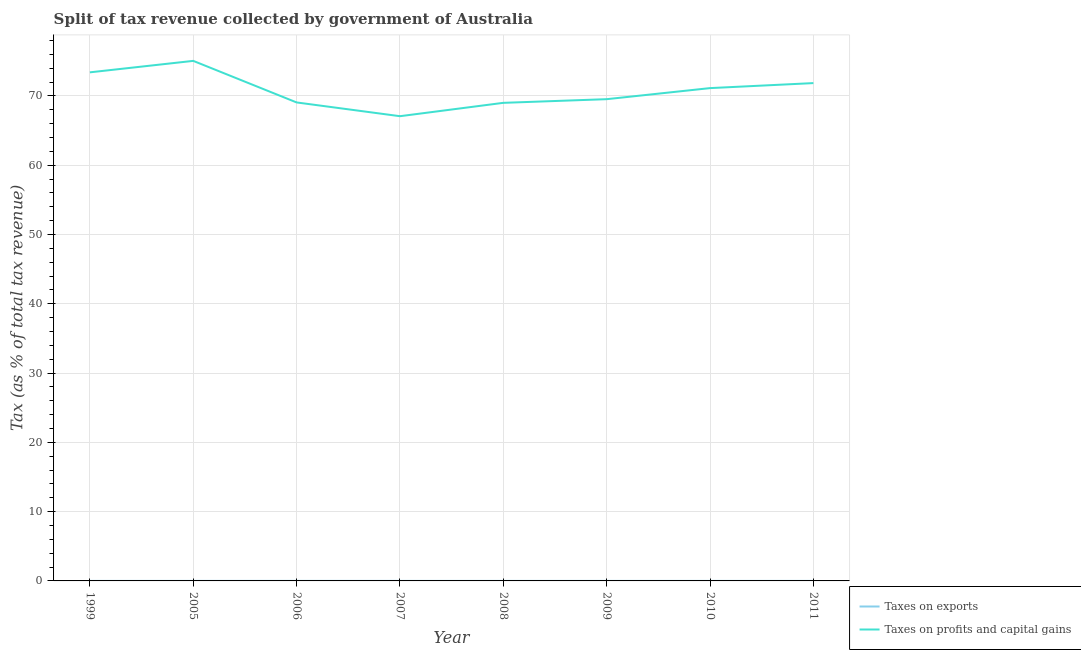Is the number of lines equal to the number of legend labels?
Make the answer very short. Yes. What is the percentage of revenue obtained from taxes on exports in 2006?
Provide a succinct answer. 0.01. Across all years, what is the maximum percentage of revenue obtained from taxes on exports?
Make the answer very short. 0.01. Across all years, what is the minimum percentage of revenue obtained from taxes on profits and capital gains?
Offer a terse response. 67.07. What is the total percentage of revenue obtained from taxes on profits and capital gains in the graph?
Offer a terse response. 566.1. What is the difference between the percentage of revenue obtained from taxes on profits and capital gains in 2009 and that in 2010?
Your answer should be very brief. -1.6. What is the difference between the percentage of revenue obtained from taxes on exports in 2007 and the percentage of revenue obtained from taxes on profits and capital gains in 2010?
Keep it short and to the point. -71.12. What is the average percentage of revenue obtained from taxes on profits and capital gains per year?
Offer a very short reply. 70.76. In the year 2007, what is the difference between the percentage of revenue obtained from taxes on profits and capital gains and percentage of revenue obtained from taxes on exports?
Keep it short and to the point. 67.07. What is the ratio of the percentage of revenue obtained from taxes on exports in 2008 to that in 2010?
Make the answer very short. 0.67. Is the percentage of revenue obtained from taxes on exports in 2005 less than that in 2006?
Keep it short and to the point. Yes. What is the difference between the highest and the second highest percentage of revenue obtained from taxes on profits and capital gains?
Your response must be concise. 1.65. What is the difference between the highest and the lowest percentage of revenue obtained from taxes on profits and capital gains?
Your answer should be very brief. 7.98. In how many years, is the percentage of revenue obtained from taxes on profits and capital gains greater than the average percentage of revenue obtained from taxes on profits and capital gains taken over all years?
Keep it short and to the point. 4. Is the percentage of revenue obtained from taxes on profits and capital gains strictly less than the percentage of revenue obtained from taxes on exports over the years?
Offer a terse response. No. How many lines are there?
Keep it short and to the point. 2. Are the values on the major ticks of Y-axis written in scientific E-notation?
Make the answer very short. No. Does the graph contain any zero values?
Keep it short and to the point. No. Does the graph contain grids?
Offer a very short reply. Yes. Where does the legend appear in the graph?
Keep it short and to the point. Bottom right. How many legend labels are there?
Your answer should be very brief. 2. How are the legend labels stacked?
Your response must be concise. Vertical. What is the title of the graph?
Your response must be concise. Split of tax revenue collected by government of Australia. Does "Mineral" appear as one of the legend labels in the graph?
Your answer should be compact. No. What is the label or title of the Y-axis?
Provide a succinct answer. Tax (as % of total tax revenue). What is the Tax (as % of total tax revenue) in Taxes on exports in 1999?
Your answer should be very brief. 0. What is the Tax (as % of total tax revenue) of Taxes on profits and capital gains in 1999?
Your answer should be compact. 73.4. What is the Tax (as % of total tax revenue) of Taxes on exports in 2005?
Offer a very short reply. 0.01. What is the Tax (as % of total tax revenue) of Taxes on profits and capital gains in 2005?
Give a very brief answer. 75.06. What is the Tax (as % of total tax revenue) of Taxes on exports in 2006?
Provide a succinct answer. 0.01. What is the Tax (as % of total tax revenue) in Taxes on profits and capital gains in 2006?
Make the answer very short. 69.06. What is the Tax (as % of total tax revenue) in Taxes on exports in 2007?
Give a very brief answer. 0.01. What is the Tax (as % of total tax revenue) of Taxes on profits and capital gains in 2007?
Your response must be concise. 67.07. What is the Tax (as % of total tax revenue) in Taxes on exports in 2008?
Provide a succinct answer. 0. What is the Tax (as % of total tax revenue) of Taxes on profits and capital gains in 2008?
Ensure brevity in your answer.  69. What is the Tax (as % of total tax revenue) in Taxes on exports in 2009?
Keep it short and to the point. 0. What is the Tax (as % of total tax revenue) of Taxes on profits and capital gains in 2009?
Ensure brevity in your answer.  69.53. What is the Tax (as % of total tax revenue) in Taxes on exports in 2010?
Ensure brevity in your answer.  0.01. What is the Tax (as % of total tax revenue) in Taxes on profits and capital gains in 2010?
Your response must be concise. 71.13. What is the Tax (as % of total tax revenue) in Taxes on exports in 2011?
Provide a succinct answer. 0. What is the Tax (as % of total tax revenue) of Taxes on profits and capital gains in 2011?
Your answer should be compact. 71.85. Across all years, what is the maximum Tax (as % of total tax revenue) in Taxes on exports?
Keep it short and to the point. 0.01. Across all years, what is the maximum Tax (as % of total tax revenue) in Taxes on profits and capital gains?
Your response must be concise. 75.06. Across all years, what is the minimum Tax (as % of total tax revenue) in Taxes on exports?
Provide a short and direct response. 0. Across all years, what is the minimum Tax (as % of total tax revenue) in Taxes on profits and capital gains?
Give a very brief answer. 67.07. What is the total Tax (as % of total tax revenue) of Taxes on exports in the graph?
Give a very brief answer. 0.04. What is the total Tax (as % of total tax revenue) of Taxes on profits and capital gains in the graph?
Ensure brevity in your answer.  566.1. What is the difference between the Tax (as % of total tax revenue) of Taxes on exports in 1999 and that in 2005?
Give a very brief answer. -0. What is the difference between the Tax (as % of total tax revenue) in Taxes on profits and capital gains in 1999 and that in 2005?
Make the answer very short. -1.65. What is the difference between the Tax (as % of total tax revenue) of Taxes on exports in 1999 and that in 2006?
Give a very brief answer. -0. What is the difference between the Tax (as % of total tax revenue) of Taxes on profits and capital gains in 1999 and that in 2006?
Offer a terse response. 4.34. What is the difference between the Tax (as % of total tax revenue) in Taxes on exports in 1999 and that in 2007?
Offer a terse response. -0. What is the difference between the Tax (as % of total tax revenue) in Taxes on profits and capital gains in 1999 and that in 2007?
Provide a short and direct response. 6.33. What is the difference between the Tax (as % of total tax revenue) in Taxes on exports in 1999 and that in 2008?
Your answer should be compact. -0. What is the difference between the Tax (as % of total tax revenue) of Taxes on profits and capital gains in 1999 and that in 2008?
Your response must be concise. 4.4. What is the difference between the Tax (as % of total tax revenue) of Taxes on exports in 1999 and that in 2009?
Provide a short and direct response. -0. What is the difference between the Tax (as % of total tax revenue) of Taxes on profits and capital gains in 1999 and that in 2009?
Provide a succinct answer. 3.87. What is the difference between the Tax (as % of total tax revenue) of Taxes on exports in 1999 and that in 2010?
Your response must be concise. -0. What is the difference between the Tax (as % of total tax revenue) of Taxes on profits and capital gains in 1999 and that in 2010?
Give a very brief answer. 2.28. What is the difference between the Tax (as % of total tax revenue) of Taxes on exports in 1999 and that in 2011?
Make the answer very short. -0. What is the difference between the Tax (as % of total tax revenue) in Taxes on profits and capital gains in 1999 and that in 2011?
Provide a succinct answer. 1.55. What is the difference between the Tax (as % of total tax revenue) in Taxes on exports in 2005 and that in 2006?
Give a very brief answer. -0. What is the difference between the Tax (as % of total tax revenue) of Taxes on profits and capital gains in 2005 and that in 2006?
Give a very brief answer. 6. What is the difference between the Tax (as % of total tax revenue) in Taxes on exports in 2005 and that in 2007?
Your answer should be compact. -0. What is the difference between the Tax (as % of total tax revenue) in Taxes on profits and capital gains in 2005 and that in 2007?
Offer a terse response. 7.98. What is the difference between the Tax (as % of total tax revenue) of Taxes on exports in 2005 and that in 2008?
Give a very brief answer. 0. What is the difference between the Tax (as % of total tax revenue) in Taxes on profits and capital gains in 2005 and that in 2008?
Your response must be concise. 6.06. What is the difference between the Tax (as % of total tax revenue) in Taxes on exports in 2005 and that in 2009?
Make the answer very short. 0. What is the difference between the Tax (as % of total tax revenue) of Taxes on profits and capital gains in 2005 and that in 2009?
Provide a short and direct response. 5.53. What is the difference between the Tax (as % of total tax revenue) in Taxes on profits and capital gains in 2005 and that in 2010?
Give a very brief answer. 3.93. What is the difference between the Tax (as % of total tax revenue) in Taxes on exports in 2005 and that in 2011?
Provide a short and direct response. 0. What is the difference between the Tax (as % of total tax revenue) of Taxes on profits and capital gains in 2005 and that in 2011?
Offer a terse response. 3.21. What is the difference between the Tax (as % of total tax revenue) of Taxes on exports in 2006 and that in 2007?
Make the answer very short. 0. What is the difference between the Tax (as % of total tax revenue) of Taxes on profits and capital gains in 2006 and that in 2007?
Give a very brief answer. 1.98. What is the difference between the Tax (as % of total tax revenue) in Taxes on exports in 2006 and that in 2008?
Give a very brief answer. 0. What is the difference between the Tax (as % of total tax revenue) of Taxes on profits and capital gains in 2006 and that in 2008?
Ensure brevity in your answer.  0.06. What is the difference between the Tax (as % of total tax revenue) of Taxes on exports in 2006 and that in 2009?
Give a very brief answer. 0. What is the difference between the Tax (as % of total tax revenue) of Taxes on profits and capital gains in 2006 and that in 2009?
Your answer should be very brief. -0.47. What is the difference between the Tax (as % of total tax revenue) of Taxes on profits and capital gains in 2006 and that in 2010?
Offer a terse response. -2.07. What is the difference between the Tax (as % of total tax revenue) of Taxes on exports in 2006 and that in 2011?
Make the answer very short. 0. What is the difference between the Tax (as % of total tax revenue) of Taxes on profits and capital gains in 2006 and that in 2011?
Offer a terse response. -2.79. What is the difference between the Tax (as % of total tax revenue) of Taxes on exports in 2007 and that in 2008?
Provide a succinct answer. 0. What is the difference between the Tax (as % of total tax revenue) of Taxes on profits and capital gains in 2007 and that in 2008?
Ensure brevity in your answer.  -1.93. What is the difference between the Tax (as % of total tax revenue) of Taxes on exports in 2007 and that in 2009?
Your response must be concise. 0. What is the difference between the Tax (as % of total tax revenue) of Taxes on profits and capital gains in 2007 and that in 2009?
Your answer should be compact. -2.46. What is the difference between the Tax (as % of total tax revenue) in Taxes on exports in 2007 and that in 2010?
Give a very brief answer. 0. What is the difference between the Tax (as % of total tax revenue) in Taxes on profits and capital gains in 2007 and that in 2010?
Give a very brief answer. -4.05. What is the difference between the Tax (as % of total tax revenue) of Taxes on exports in 2007 and that in 2011?
Give a very brief answer. 0. What is the difference between the Tax (as % of total tax revenue) in Taxes on profits and capital gains in 2007 and that in 2011?
Your response must be concise. -4.78. What is the difference between the Tax (as % of total tax revenue) of Taxes on exports in 2008 and that in 2009?
Give a very brief answer. -0. What is the difference between the Tax (as % of total tax revenue) in Taxes on profits and capital gains in 2008 and that in 2009?
Your answer should be compact. -0.53. What is the difference between the Tax (as % of total tax revenue) of Taxes on exports in 2008 and that in 2010?
Provide a succinct answer. -0. What is the difference between the Tax (as % of total tax revenue) in Taxes on profits and capital gains in 2008 and that in 2010?
Your answer should be very brief. -2.13. What is the difference between the Tax (as % of total tax revenue) in Taxes on exports in 2008 and that in 2011?
Your response must be concise. -0. What is the difference between the Tax (as % of total tax revenue) of Taxes on profits and capital gains in 2008 and that in 2011?
Your answer should be compact. -2.85. What is the difference between the Tax (as % of total tax revenue) of Taxes on exports in 2009 and that in 2010?
Your answer should be very brief. -0. What is the difference between the Tax (as % of total tax revenue) of Taxes on profits and capital gains in 2009 and that in 2010?
Keep it short and to the point. -1.6. What is the difference between the Tax (as % of total tax revenue) of Taxes on exports in 2009 and that in 2011?
Provide a short and direct response. 0. What is the difference between the Tax (as % of total tax revenue) of Taxes on profits and capital gains in 2009 and that in 2011?
Your answer should be compact. -2.32. What is the difference between the Tax (as % of total tax revenue) of Taxes on exports in 2010 and that in 2011?
Keep it short and to the point. 0. What is the difference between the Tax (as % of total tax revenue) of Taxes on profits and capital gains in 2010 and that in 2011?
Offer a very short reply. -0.72. What is the difference between the Tax (as % of total tax revenue) of Taxes on exports in 1999 and the Tax (as % of total tax revenue) of Taxes on profits and capital gains in 2005?
Your answer should be very brief. -75.05. What is the difference between the Tax (as % of total tax revenue) of Taxes on exports in 1999 and the Tax (as % of total tax revenue) of Taxes on profits and capital gains in 2006?
Your answer should be compact. -69.06. What is the difference between the Tax (as % of total tax revenue) in Taxes on exports in 1999 and the Tax (as % of total tax revenue) in Taxes on profits and capital gains in 2007?
Offer a terse response. -67.07. What is the difference between the Tax (as % of total tax revenue) in Taxes on exports in 1999 and the Tax (as % of total tax revenue) in Taxes on profits and capital gains in 2008?
Your answer should be very brief. -69. What is the difference between the Tax (as % of total tax revenue) in Taxes on exports in 1999 and the Tax (as % of total tax revenue) in Taxes on profits and capital gains in 2009?
Offer a very short reply. -69.53. What is the difference between the Tax (as % of total tax revenue) of Taxes on exports in 1999 and the Tax (as % of total tax revenue) of Taxes on profits and capital gains in 2010?
Your answer should be compact. -71.12. What is the difference between the Tax (as % of total tax revenue) of Taxes on exports in 1999 and the Tax (as % of total tax revenue) of Taxes on profits and capital gains in 2011?
Offer a terse response. -71.85. What is the difference between the Tax (as % of total tax revenue) in Taxes on exports in 2005 and the Tax (as % of total tax revenue) in Taxes on profits and capital gains in 2006?
Offer a very short reply. -69.05. What is the difference between the Tax (as % of total tax revenue) of Taxes on exports in 2005 and the Tax (as % of total tax revenue) of Taxes on profits and capital gains in 2007?
Offer a very short reply. -67.07. What is the difference between the Tax (as % of total tax revenue) of Taxes on exports in 2005 and the Tax (as % of total tax revenue) of Taxes on profits and capital gains in 2008?
Give a very brief answer. -69. What is the difference between the Tax (as % of total tax revenue) of Taxes on exports in 2005 and the Tax (as % of total tax revenue) of Taxes on profits and capital gains in 2009?
Give a very brief answer. -69.52. What is the difference between the Tax (as % of total tax revenue) of Taxes on exports in 2005 and the Tax (as % of total tax revenue) of Taxes on profits and capital gains in 2010?
Offer a very short reply. -71.12. What is the difference between the Tax (as % of total tax revenue) in Taxes on exports in 2005 and the Tax (as % of total tax revenue) in Taxes on profits and capital gains in 2011?
Ensure brevity in your answer.  -71.85. What is the difference between the Tax (as % of total tax revenue) of Taxes on exports in 2006 and the Tax (as % of total tax revenue) of Taxes on profits and capital gains in 2007?
Offer a very short reply. -67.07. What is the difference between the Tax (as % of total tax revenue) in Taxes on exports in 2006 and the Tax (as % of total tax revenue) in Taxes on profits and capital gains in 2008?
Provide a short and direct response. -69. What is the difference between the Tax (as % of total tax revenue) of Taxes on exports in 2006 and the Tax (as % of total tax revenue) of Taxes on profits and capital gains in 2009?
Make the answer very short. -69.52. What is the difference between the Tax (as % of total tax revenue) of Taxes on exports in 2006 and the Tax (as % of total tax revenue) of Taxes on profits and capital gains in 2010?
Keep it short and to the point. -71.12. What is the difference between the Tax (as % of total tax revenue) of Taxes on exports in 2006 and the Tax (as % of total tax revenue) of Taxes on profits and capital gains in 2011?
Provide a short and direct response. -71.85. What is the difference between the Tax (as % of total tax revenue) in Taxes on exports in 2007 and the Tax (as % of total tax revenue) in Taxes on profits and capital gains in 2008?
Your response must be concise. -69. What is the difference between the Tax (as % of total tax revenue) in Taxes on exports in 2007 and the Tax (as % of total tax revenue) in Taxes on profits and capital gains in 2009?
Ensure brevity in your answer.  -69.52. What is the difference between the Tax (as % of total tax revenue) of Taxes on exports in 2007 and the Tax (as % of total tax revenue) of Taxes on profits and capital gains in 2010?
Provide a short and direct response. -71.12. What is the difference between the Tax (as % of total tax revenue) in Taxes on exports in 2007 and the Tax (as % of total tax revenue) in Taxes on profits and capital gains in 2011?
Provide a succinct answer. -71.85. What is the difference between the Tax (as % of total tax revenue) in Taxes on exports in 2008 and the Tax (as % of total tax revenue) in Taxes on profits and capital gains in 2009?
Offer a very short reply. -69.53. What is the difference between the Tax (as % of total tax revenue) of Taxes on exports in 2008 and the Tax (as % of total tax revenue) of Taxes on profits and capital gains in 2010?
Offer a very short reply. -71.12. What is the difference between the Tax (as % of total tax revenue) of Taxes on exports in 2008 and the Tax (as % of total tax revenue) of Taxes on profits and capital gains in 2011?
Ensure brevity in your answer.  -71.85. What is the difference between the Tax (as % of total tax revenue) of Taxes on exports in 2009 and the Tax (as % of total tax revenue) of Taxes on profits and capital gains in 2010?
Give a very brief answer. -71.12. What is the difference between the Tax (as % of total tax revenue) in Taxes on exports in 2009 and the Tax (as % of total tax revenue) in Taxes on profits and capital gains in 2011?
Your answer should be compact. -71.85. What is the difference between the Tax (as % of total tax revenue) in Taxes on exports in 2010 and the Tax (as % of total tax revenue) in Taxes on profits and capital gains in 2011?
Your response must be concise. -71.85. What is the average Tax (as % of total tax revenue) in Taxes on exports per year?
Your response must be concise. 0. What is the average Tax (as % of total tax revenue) in Taxes on profits and capital gains per year?
Offer a terse response. 70.76. In the year 1999, what is the difference between the Tax (as % of total tax revenue) in Taxes on exports and Tax (as % of total tax revenue) in Taxes on profits and capital gains?
Your answer should be very brief. -73.4. In the year 2005, what is the difference between the Tax (as % of total tax revenue) in Taxes on exports and Tax (as % of total tax revenue) in Taxes on profits and capital gains?
Keep it short and to the point. -75.05. In the year 2006, what is the difference between the Tax (as % of total tax revenue) in Taxes on exports and Tax (as % of total tax revenue) in Taxes on profits and capital gains?
Provide a succinct answer. -69.05. In the year 2007, what is the difference between the Tax (as % of total tax revenue) in Taxes on exports and Tax (as % of total tax revenue) in Taxes on profits and capital gains?
Your answer should be very brief. -67.07. In the year 2008, what is the difference between the Tax (as % of total tax revenue) of Taxes on exports and Tax (as % of total tax revenue) of Taxes on profits and capital gains?
Ensure brevity in your answer.  -69. In the year 2009, what is the difference between the Tax (as % of total tax revenue) in Taxes on exports and Tax (as % of total tax revenue) in Taxes on profits and capital gains?
Your answer should be very brief. -69.53. In the year 2010, what is the difference between the Tax (as % of total tax revenue) in Taxes on exports and Tax (as % of total tax revenue) in Taxes on profits and capital gains?
Keep it short and to the point. -71.12. In the year 2011, what is the difference between the Tax (as % of total tax revenue) of Taxes on exports and Tax (as % of total tax revenue) of Taxes on profits and capital gains?
Provide a short and direct response. -71.85. What is the ratio of the Tax (as % of total tax revenue) of Taxes on exports in 1999 to that in 2005?
Make the answer very short. 0.55. What is the ratio of the Tax (as % of total tax revenue) of Taxes on profits and capital gains in 1999 to that in 2005?
Give a very brief answer. 0.98. What is the ratio of the Tax (as % of total tax revenue) of Taxes on exports in 1999 to that in 2006?
Keep it short and to the point. 0.5. What is the ratio of the Tax (as % of total tax revenue) in Taxes on profits and capital gains in 1999 to that in 2006?
Provide a succinct answer. 1.06. What is the ratio of the Tax (as % of total tax revenue) of Taxes on exports in 1999 to that in 2007?
Ensure brevity in your answer.  0.54. What is the ratio of the Tax (as % of total tax revenue) in Taxes on profits and capital gains in 1999 to that in 2007?
Offer a very short reply. 1.09. What is the ratio of the Tax (as % of total tax revenue) of Taxes on exports in 1999 to that in 2008?
Ensure brevity in your answer.  0.82. What is the ratio of the Tax (as % of total tax revenue) of Taxes on profits and capital gains in 1999 to that in 2008?
Make the answer very short. 1.06. What is the ratio of the Tax (as % of total tax revenue) of Taxes on exports in 1999 to that in 2009?
Your answer should be compact. 0.61. What is the ratio of the Tax (as % of total tax revenue) of Taxes on profits and capital gains in 1999 to that in 2009?
Your answer should be very brief. 1.06. What is the ratio of the Tax (as % of total tax revenue) in Taxes on exports in 1999 to that in 2010?
Provide a short and direct response. 0.55. What is the ratio of the Tax (as % of total tax revenue) of Taxes on profits and capital gains in 1999 to that in 2010?
Your answer should be very brief. 1.03. What is the ratio of the Tax (as % of total tax revenue) in Taxes on exports in 1999 to that in 2011?
Keep it short and to the point. 0.75. What is the ratio of the Tax (as % of total tax revenue) of Taxes on profits and capital gains in 1999 to that in 2011?
Make the answer very short. 1.02. What is the ratio of the Tax (as % of total tax revenue) in Taxes on exports in 2005 to that in 2006?
Provide a short and direct response. 0.92. What is the ratio of the Tax (as % of total tax revenue) in Taxes on profits and capital gains in 2005 to that in 2006?
Provide a succinct answer. 1.09. What is the ratio of the Tax (as % of total tax revenue) of Taxes on profits and capital gains in 2005 to that in 2007?
Offer a terse response. 1.12. What is the ratio of the Tax (as % of total tax revenue) of Taxes on exports in 2005 to that in 2008?
Provide a short and direct response. 1.5. What is the ratio of the Tax (as % of total tax revenue) in Taxes on profits and capital gains in 2005 to that in 2008?
Make the answer very short. 1.09. What is the ratio of the Tax (as % of total tax revenue) of Taxes on exports in 2005 to that in 2009?
Provide a short and direct response. 1.12. What is the ratio of the Tax (as % of total tax revenue) of Taxes on profits and capital gains in 2005 to that in 2009?
Provide a short and direct response. 1.08. What is the ratio of the Tax (as % of total tax revenue) in Taxes on profits and capital gains in 2005 to that in 2010?
Make the answer very short. 1.06. What is the ratio of the Tax (as % of total tax revenue) in Taxes on exports in 2005 to that in 2011?
Your answer should be very brief. 1.37. What is the ratio of the Tax (as % of total tax revenue) in Taxes on profits and capital gains in 2005 to that in 2011?
Your response must be concise. 1.04. What is the ratio of the Tax (as % of total tax revenue) in Taxes on exports in 2006 to that in 2007?
Offer a terse response. 1.07. What is the ratio of the Tax (as % of total tax revenue) in Taxes on profits and capital gains in 2006 to that in 2007?
Your answer should be very brief. 1.03. What is the ratio of the Tax (as % of total tax revenue) of Taxes on exports in 2006 to that in 2008?
Offer a terse response. 1.63. What is the ratio of the Tax (as % of total tax revenue) in Taxes on profits and capital gains in 2006 to that in 2008?
Give a very brief answer. 1. What is the ratio of the Tax (as % of total tax revenue) of Taxes on exports in 2006 to that in 2009?
Provide a succinct answer. 1.22. What is the ratio of the Tax (as % of total tax revenue) of Taxes on profits and capital gains in 2006 to that in 2009?
Your answer should be compact. 0.99. What is the ratio of the Tax (as % of total tax revenue) in Taxes on exports in 2006 to that in 2010?
Make the answer very short. 1.09. What is the ratio of the Tax (as % of total tax revenue) in Taxes on profits and capital gains in 2006 to that in 2010?
Your answer should be compact. 0.97. What is the ratio of the Tax (as % of total tax revenue) of Taxes on exports in 2006 to that in 2011?
Your answer should be compact. 1.5. What is the ratio of the Tax (as % of total tax revenue) in Taxes on profits and capital gains in 2006 to that in 2011?
Your response must be concise. 0.96. What is the ratio of the Tax (as % of total tax revenue) of Taxes on exports in 2007 to that in 2008?
Keep it short and to the point. 1.53. What is the ratio of the Tax (as % of total tax revenue) in Taxes on profits and capital gains in 2007 to that in 2008?
Your answer should be very brief. 0.97. What is the ratio of the Tax (as % of total tax revenue) in Taxes on exports in 2007 to that in 2009?
Your answer should be compact. 1.14. What is the ratio of the Tax (as % of total tax revenue) of Taxes on profits and capital gains in 2007 to that in 2009?
Keep it short and to the point. 0.96. What is the ratio of the Tax (as % of total tax revenue) in Taxes on exports in 2007 to that in 2010?
Ensure brevity in your answer.  1.02. What is the ratio of the Tax (as % of total tax revenue) of Taxes on profits and capital gains in 2007 to that in 2010?
Your response must be concise. 0.94. What is the ratio of the Tax (as % of total tax revenue) of Taxes on exports in 2007 to that in 2011?
Give a very brief answer. 1.4. What is the ratio of the Tax (as % of total tax revenue) of Taxes on profits and capital gains in 2007 to that in 2011?
Ensure brevity in your answer.  0.93. What is the ratio of the Tax (as % of total tax revenue) in Taxes on exports in 2008 to that in 2009?
Your response must be concise. 0.75. What is the ratio of the Tax (as % of total tax revenue) of Taxes on profits and capital gains in 2008 to that in 2009?
Provide a succinct answer. 0.99. What is the ratio of the Tax (as % of total tax revenue) of Taxes on exports in 2008 to that in 2010?
Your answer should be very brief. 0.67. What is the ratio of the Tax (as % of total tax revenue) of Taxes on profits and capital gains in 2008 to that in 2010?
Give a very brief answer. 0.97. What is the ratio of the Tax (as % of total tax revenue) of Taxes on exports in 2008 to that in 2011?
Offer a very short reply. 0.92. What is the ratio of the Tax (as % of total tax revenue) in Taxes on profits and capital gains in 2008 to that in 2011?
Your answer should be compact. 0.96. What is the ratio of the Tax (as % of total tax revenue) of Taxes on exports in 2009 to that in 2010?
Your answer should be very brief. 0.89. What is the ratio of the Tax (as % of total tax revenue) of Taxes on profits and capital gains in 2009 to that in 2010?
Offer a very short reply. 0.98. What is the ratio of the Tax (as % of total tax revenue) of Taxes on exports in 2009 to that in 2011?
Provide a short and direct response. 1.22. What is the ratio of the Tax (as % of total tax revenue) of Taxes on exports in 2010 to that in 2011?
Provide a succinct answer. 1.37. What is the ratio of the Tax (as % of total tax revenue) of Taxes on profits and capital gains in 2010 to that in 2011?
Provide a short and direct response. 0.99. What is the difference between the highest and the second highest Tax (as % of total tax revenue) in Taxes on exports?
Make the answer very short. 0. What is the difference between the highest and the second highest Tax (as % of total tax revenue) in Taxes on profits and capital gains?
Your answer should be compact. 1.65. What is the difference between the highest and the lowest Tax (as % of total tax revenue) in Taxes on exports?
Offer a very short reply. 0. What is the difference between the highest and the lowest Tax (as % of total tax revenue) in Taxes on profits and capital gains?
Provide a short and direct response. 7.98. 